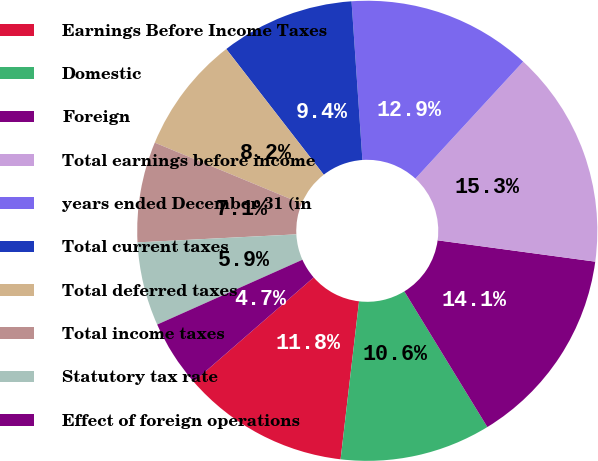Convert chart. <chart><loc_0><loc_0><loc_500><loc_500><pie_chart><fcel>Earnings Before Income Taxes<fcel>Domestic<fcel>Foreign<fcel>Total earnings before income<fcel>years ended December 31 (in<fcel>Total current taxes<fcel>Total deferred taxes<fcel>Total income taxes<fcel>Statutory tax rate<fcel>Effect of foreign operations<nl><fcel>11.76%<fcel>10.59%<fcel>14.12%<fcel>15.29%<fcel>12.94%<fcel>9.41%<fcel>8.24%<fcel>7.06%<fcel>5.88%<fcel>4.71%<nl></chart> 